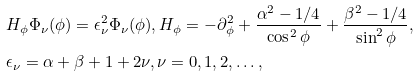Convert formula to latex. <formula><loc_0><loc_0><loc_500><loc_500>& H _ { \phi } \Phi _ { \nu } ( \phi ) = \epsilon _ { \nu } ^ { 2 } \Phi _ { \nu } ( \phi ) , H _ { \phi } = - \partial _ { \phi } ^ { 2 } + \frac { \alpha ^ { 2 } - 1 / 4 } { \cos ^ { 2 } \phi } + \frac { \beta ^ { 2 } - 1 / 4 } { \sin ^ { 2 } \phi } , \\ & \epsilon _ { \nu } = \alpha + \beta + 1 + 2 \nu , \nu = 0 , 1 , 2 , \dots ,</formula> 